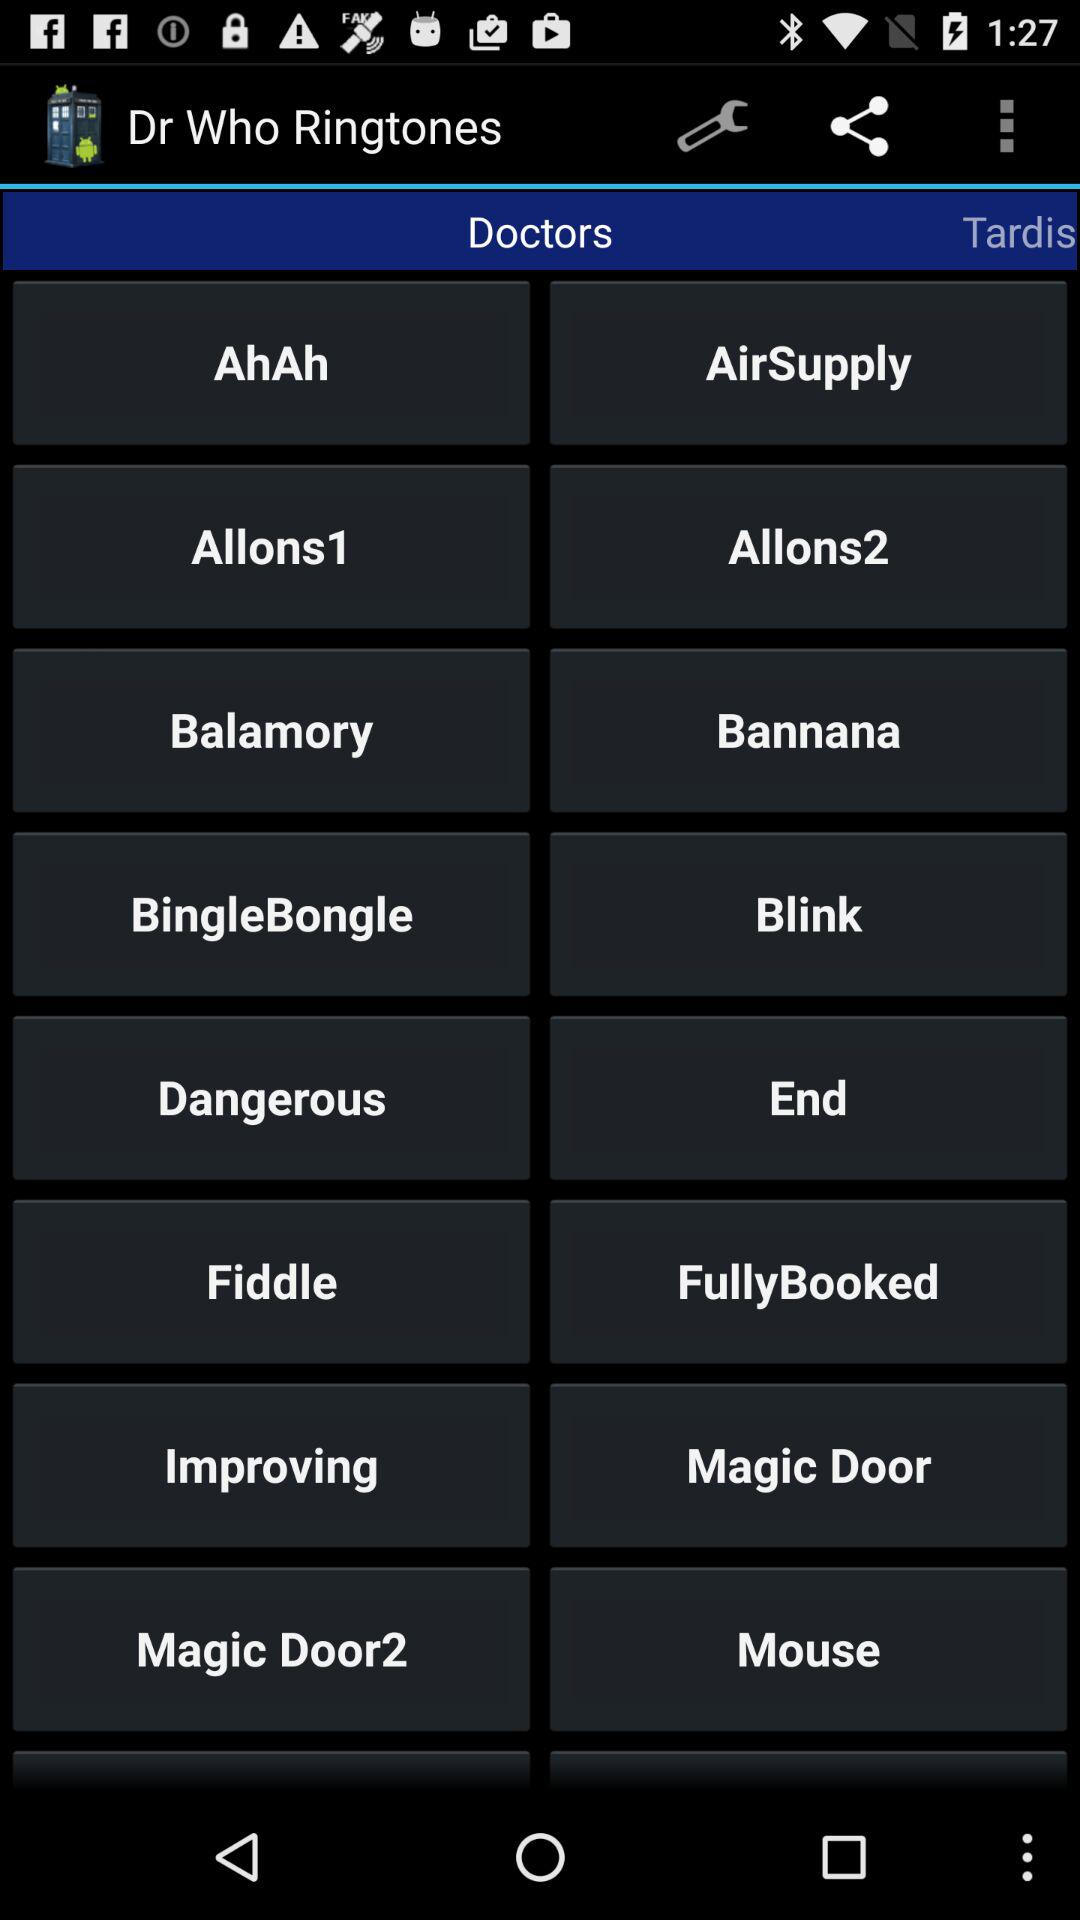What is the application name? The application name is "Dr Who Ringtones". 